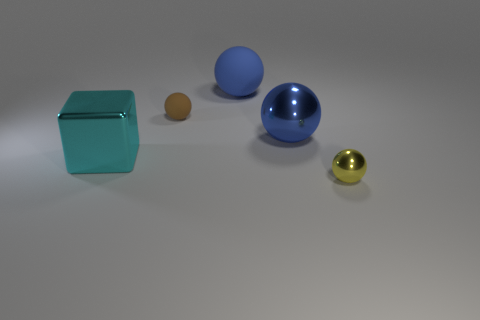The small thing that is to the left of the small sphere that is on the right side of the tiny thing behind the cyan object is what shape?
Your answer should be compact. Sphere. There is a shiny cube that is the same size as the blue matte sphere; what color is it?
Your response must be concise. Cyan. How many other metallic objects have the same shape as the yellow thing?
Your answer should be very brief. 1. Does the blue rubber sphere have the same size as the blue ball in front of the tiny matte sphere?
Offer a terse response. Yes. The tiny shiny thing to the right of the tiny object that is on the left side of the tiny shiny object is what shape?
Your answer should be compact. Sphere. Are there fewer blue objects that are in front of the blue metallic thing than tiny yellow things?
Offer a very short reply. Yes. What number of cyan blocks are the same size as the blue rubber thing?
Keep it short and to the point. 1. There is a big thing behind the blue shiny thing; what shape is it?
Give a very brief answer. Sphere. Is the number of tiny shiny things less than the number of small gray shiny balls?
Your answer should be compact. No. Is there any other thing that is the same color as the shiny cube?
Make the answer very short. No. 